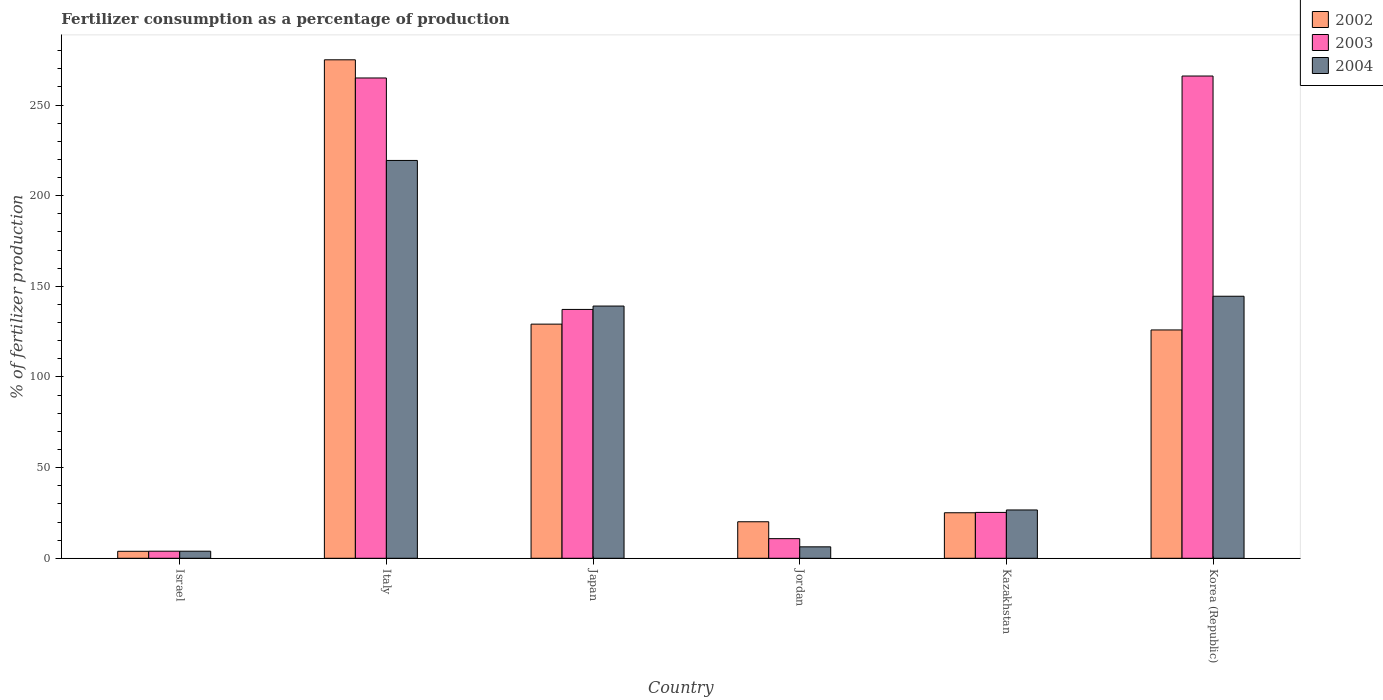How many different coloured bars are there?
Make the answer very short. 3. How many groups of bars are there?
Ensure brevity in your answer.  6. Are the number of bars per tick equal to the number of legend labels?
Keep it short and to the point. Yes. Are the number of bars on each tick of the X-axis equal?
Your response must be concise. Yes. How many bars are there on the 6th tick from the left?
Your response must be concise. 3. In how many cases, is the number of bars for a given country not equal to the number of legend labels?
Make the answer very short. 0. What is the percentage of fertilizers consumed in 2003 in Japan?
Ensure brevity in your answer.  137.27. Across all countries, what is the maximum percentage of fertilizers consumed in 2003?
Your answer should be very brief. 266.02. Across all countries, what is the minimum percentage of fertilizers consumed in 2002?
Your answer should be compact. 3.85. In which country was the percentage of fertilizers consumed in 2003 minimum?
Offer a terse response. Israel. What is the total percentage of fertilizers consumed in 2004 in the graph?
Give a very brief answer. 539.98. What is the difference between the percentage of fertilizers consumed in 2004 in Israel and that in Korea (Republic)?
Your answer should be compact. -140.63. What is the difference between the percentage of fertilizers consumed in 2002 in Jordan and the percentage of fertilizers consumed in 2004 in Korea (Republic)?
Offer a very short reply. -124.39. What is the average percentage of fertilizers consumed in 2003 per country?
Offer a terse response. 118.04. What is the difference between the percentage of fertilizers consumed of/in 2004 and percentage of fertilizers consumed of/in 2002 in Israel?
Provide a succinct answer. 0.05. In how many countries, is the percentage of fertilizers consumed in 2003 greater than 30 %?
Offer a terse response. 3. What is the ratio of the percentage of fertilizers consumed in 2003 in Jordan to that in Korea (Republic)?
Keep it short and to the point. 0.04. What is the difference between the highest and the second highest percentage of fertilizers consumed in 2004?
Your answer should be compact. -74.91. What is the difference between the highest and the lowest percentage of fertilizers consumed in 2004?
Keep it short and to the point. 215.54. Is the sum of the percentage of fertilizers consumed in 2002 in Japan and Jordan greater than the maximum percentage of fertilizers consumed in 2003 across all countries?
Keep it short and to the point. No. What does the 1st bar from the left in Italy represents?
Offer a very short reply. 2002. What does the 2nd bar from the right in Japan represents?
Your answer should be very brief. 2003. Is it the case that in every country, the sum of the percentage of fertilizers consumed in 2004 and percentage of fertilizers consumed in 2003 is greater than the percentage of fertilizers consumed in 2002?
Provide a succinct answer. No. Are all the bars in the graph horizontal?
Your response must be concise. No. How many countries are there in the graph?
Ensure brevity in your answer.  6. What is the difference between two consecutive major ticks on the Y-axis?
Your answer should be very brief. 50. Does the graph contain any zero values?
Offer a very short reply. No. Where does the legend appear in the graph?
Provide a short and direct response. Top right. How many legend labels are there?
Provide a succinct answer. 3. How are the legend labels stacked?
Make the answer very short. Vertical. What is the title of the graph?
Your response must be concise. Fertilizer consumption as a percentage of production. Does "2009" appear as one of the legend labels in the graph?
Your response must be concise. No. What is the label or title of the Y-axis?
Provide a short and direct response. % of fertilizer production. What is the % of fertilizer production of 2002 in Israel?
Keep it short and to the point. 3.85. What is the % of fertilizer production of 2003 in Israel?
Ensure brevity in your answer.  3.9. What is the % of fertilizer production of 2004 in Israel?
Ensure brevity in your answer.  3.9. What is the % of fertilizer production of 2002 in Italy?
Ensure brevity in your answer.  274.97. What is the % of fertilizer production in 2003 in Italy?
Your answer should be compact. 264.94. What is the % of fertilizer production of 2004 in Italy?
Your answer should be very brief. 219.45. What is the % of fertilizer production of 2002 in Japan?
Provide a short and direct response. 129.16. What is the % of fertilizer production of 2003 in Japan?
Offer a terse response. 137.27. What is the % of fertilizer production of 2004 in Japan?
Provide a short and direct response. 139.13. What is the % of fertilizer production in 2002 in Jordan?
Make the answer very short. 20.14. What is the % of fertilizer production of 2003 in Jordan?
Offer a very short reply. 10.83. What is the % of fertilizer production of 2004 in Jordan?
Provide a succinct answer. 6.31. What is the % of fertilizer production in 2002 in Kazakhstan?
Provide a short and direct response. 25.11. What is the % of fertilizer production in 2003 in Kazakhstan?
Make the answer very short. 25.3. What is the % of fertilizer production of 2004 in Kazakhstan?
Offer a very short reply. 26.65. What is the % of fertilizer production in 2002 in Korea (Republic)?
Provide a succinct answer. 125.95. What is the % of fertilizer production in 2003 in Korea (Republic)?
Ensure brevity in your answer.  266.02. What is the % of fertilizer production of 2004 in Korea (Republic)?
Provide a short and direct response. 144.54. Across all countries, what is the maximum % of fertilizer production of 2002?
Ensure brevity in your answer.  274.97. Across all countries, what is the maximum % of fertilizer production in 2003?
Your response must be concise. 266.02. Across all countries, what is the maximum % of fertilizer production of 2004?
Your answer should be compact. 219.45. Across all countries, what is the minimum % of fertilizer production of 2002?
Make the answer very short. 3.85. Across all countries, what is the minimum % of fertilizer production of 2003?
Your answer should be very brief. 3.9. Across all countries, what is the minimum % of fertilizer production in 2004?
Your answer should be compact. 3.9. What is the total % of fertilizer production of 2002 in the graph?
Give a very brief answer. 579.18. What is the total % of fertilizer production in 2003 in the graph?
Offer a very short reply. 708.26. What is the total % of fertilizer production in 2004 in the graph?
Make the answer very short. 539.98. What is the difference between the % of fertilizer production of 2002 in Israel and that in Italy?
Provide a short and direct response. -271.12. What is the difference between the % of fertilizer production of 2003 in Israel and that in Italy?
Provide a succinct answer. -261.04. What is the difference between the % of fertilizer production in 2004 in Israel and that in Italy?
Offer a very short reply. -215.54. What is the difference between the % of fertilizer production in 2002 in Israel and that in Japan?
Provide a succinct answer. -125.31. What is the difference between the % of fertilizer production in 2003 in Israel and that in Japan?
Your answer should be very brief. -133.36. What is the difference between the % of fertilizer production of 2004 in Israel and that in Japan?
Your answer should be very brief. -135.23. What is the difference between the % of fertilizer production in 2002 in Israel and that in Jordan?
Offer a very short reply. -16.29. What is the difference between the % of fertilizer production in 2003 in Israel and that in Jordan?
Make the answer very short. -6.92. What is the difference between the % of fertilizer production of 2004 in Israel and that in Jordan?
Offer a very short reply. -2.41. What is the difference between the % of fertilizer production of 2002 in Israel and that in Kazakhstan?
Your answer should be very brief. -21.25. What is the difference between the % of fertilizer production of 2003 in Israel and that in Kazakhstan?
Keep it short and to the point. -21.39. What is the difference between the % of fertilizer production in 2004 in Israel and that in Kazakhstan?
Provide a short and direct response. -22.74. What is the difference between the % of fertilizer production of 2002 in Israel and that in Korea (Republic)?
Your response must be concise. -122.1. What is the difference between the % of fertilizer production of 2003 in Israel and that in Korea (Republic)?
Offer a terse response. -262.12. What is the difference between the % of fertilizer production in 2004 in Israel and that in Korea (Republic)?
Offer a terse response. -140.63. What is the difference between the % of fertilizer production of 2002 in Italy and that in Japan?
Offer a very short reply. 145.81. What is the difference between the % of fertilizer production of 2003 in Italy and that in Japan?
Provide a short and direct response. 127.67. What is the difference between the % of fertilizer production of 2004 in Italy and that in Japan?
Ensure brevity in your answer.  80.32. What is the difference between the % of fertilizer production in 2002 in Italy and that in Jordan?
Give a very brief answer. 254.83. What is the difference between the % of fertilizer production in 2003 in Italy and that in Jordan?
Provide a short and direct response. 254.12. What is the difference between the % of fertilizer production in 2004 in Italy and that in Jordan?
Your response must be concise. 213.14. What is the difference between the % of fertilizer production in 2002 in Italy and that in Kazakhstan?
Provide a succinct answer. 249.86. What is the difference between the % of fertilizer production of 2003 in Italy and that in Kazakhstan?
Give a very brief answer. 239.64. What is the difference between the % of fertilizer production of 2004 in Italy and that in Kazakhstan?
Offer a terse response. 192.8. What is the difference between the % of fertilizer production of 2002 in Italy and that in Korea (Republic)?
Ensure brevity in your answer.  149.02. What is the difference between the % of fertilizer production of 2003 in Italy and that in Korea (Republic)?
Provide a succinct answer. -1.08. What is the difference between the % of fertilizer production of 2004 in Italy and that in Korea (Republic)?
Your answer should be very brief. 74.91. What is the difference between the % of fertilizer production in 2002 in Japan and that in Jordan?
Offer a very short reply. 109.02. What is the difference between the % of fertilizer production of 2003 in Japan and that in Jordan?
Your answer should be compact. 126.44. What is the difference between the % of fertilizer production of 2004 in Japan and that in Jordan?
Ensure brevity in your answer.  132.82. What is the difference between the % of fertilizer production of 2002 in Japan and that in Kazakhstan?
Make the answer very short. 104.05. What is the difference between the % of fertilizer production of 2003 in Japan and that in Kazakhstan?
Offer a terse response. 111.97. What is the difference between the % of fertilizer production of 2004 in Japan and that in Kazakhstan?
Keep it short and to the point. 112.49. What is the difference between the % of fertilizer production in 2002 in Japan and that in Korea (Republic)?
Provide a succinct answer. 3.21. What is the difference between the % of fertilizer production of 2003 in Japan and that in Korea (Republic)?
Your answer should be compact. -128.76. What is the difference between the % of fertilizer production of 2004 in Japan and that in Korea (Republic)?
Make the answer very short. -5.41. What is the difference between the % of fertilizer production in 2002 in Jordan and that in Kazakhstan?
Your response must be concise. -4.96. What is the difference between the % of fertilizer production in 2003 in Jordan and that in Kazakhstan?
Provide a succinct answer. -14.47. What is the difference between the % of fertilizer production in 2004 in Jordan and that in Kazakhstan?
Your answer should be compact. -20.34. What is the difference between the % of fertilizer production in 2002 in Jordan and that in Korea (Republic)?
Keep it short and to the point. -105.81. What is the difference between the % of fertilizer production in 2003 in Jordan and that in Korea (Republic)?
Give a very brief answer. -255.2. What is the difference between the % of fertilizer production of 2004 in Jordan and that in Korea (Republic)?
Your response must be concise. -138.23. What is the difference between the % of fertilizer production of 2002 in Kazakhstan and that in Korea (Republic)?
Your answer should be compact. -100.84. What is the difference between the % of fertilizer production in 2003 in Kazakhstan and that in Korea (Republic)?
Your answer should be very brief. -240.72. What is the difference between the % of fertilizer production in 2004 in Kazakhstan and that in Korea (Republic)?
Your answer should be compact. -117.89. What is the difference between the % of fertilizer production of 2002 in Israel and the % of fertilizer production of 2003 in Italy?
Your answer should be compact. -261.09. What is the difference between the % of fertilizer production in 2002 in Israel and the % of fertilizer production in 2004 in Italy?
Ensure brevity in your answer.  -215.59. What is the difference between the % of fertilizer production in 2003 in Israel and the % of fertilizer production in 2004 in Italy?
Offer a very short reply. -215.54. What is the difference between the % of fertilizer production in 2002 in Israel and the % of fertilizer production in 2003 in Japan?
Provide a succinct answer. -133.41. What is the difference between the % of fertilizer production of 2002 in Israel and the % of fertilizer production of 2004 in Japan?
Keep it short and to the point. -135.28. What is the difference between the % of fertilizer production in 2003 in Israel and the % of fertilizer production in 2004 in Japan?
Your answer should be very brief. -135.23. What is the difference between the % of fertilizer production in 2002 in Israel and the % of fertilizer production in 2003 in Jordan?
Keep it short and to the point. -6.97. What is the difference between the % of fertilizer production in 2002 in Israel and the % of fertilizer production in 2004 in Jordan?
Your response must be concise. -2.46. What is the difference between the % of fertilizer production of 2003 in Israel and the % of fertilizer production of 2004 in Jordan?
Your response must be concise. -2.41. What is the difference between the % of fertilizer production of 2002 in Israel and the % of fertilizer production of 2003 in Kazakhstan?
Your response must be concise. -21.45. What is the difference between the % of fertilizer production in 2002 in Israel and the % of fertilizer production in 2004 in Kazakhstan?
Your answer should be compact. -22.79. What is the difference between the % of fertilizer production in 2003 in Israel and the % of fertilizer production in 2004 in Kazakhstan?
Offer a terse response. -22.74. What is the difference between the % of fertilizer production of 2002 in Israel and the % of fertilizer production of 2003 in Korea (Republic)?
Your answer should be compact. -262.17. What is the difference between the % of fertilizer production in 2002 in Israel and the % of fertilizer production in 2004 in Korea (Republic)?
Your answer should be very brief. -140.69. What is the difference between the % of fertilizer production in 2003 in Israel and the % of fertilizer production in 2004 in Korea (Republic)?
Offer a very short reply. -140.63. What is the difference between the % of fertilizer production of 2002 in Italy and the % of fertilizer production of 2003 in Japan?
Ensure brevity in your answer.  137.7. What is the difference between the % of fertilizer production of 2002 in Italy and the % of fertilizer production of 2004 in Japan?
Offer a terse response. 135.84. What is the difference between the % of fertilizer production in 2003 in Italy and the % of fertilizer production in 2004 in Japan?
Offer a terse response. 125.81. What is the difference between the % of fertilizer production in 2002 in Italy and the % of fertilizer production in 2003 in Jordan?
Your answer should be very brief. 264.14. What is the difference between the % of fertilizer production of 2002 in Italy and the % of fertilizer production of 2004 in Jordan?
Ensure brevity in your answer.  268.66. What is the difference between the % of fertilizer production in 2003 in Italy and the % of fertilizer production in 2004 in Jordan?
Provide a short and direct response. 258.63. What is the difference between the % of fertilizer production in 2002 in Italy and the % of fertilizer production in 2003 in Kazakhstan?
Offer a very short reply. 249.67. What is the difference between the % of fertilizer production of 2002 in Italy and the % of fertilizer production of 2004 in Kazakhstan?
Ensure brevity in your answer.  248.32. What is the difference between the % of fertilizer production of 2003 in Italy and the % of fertilizer production of 2004 in Kazakhstan?
Keep it short and to the point. 238.3. What is the difference between the % of fertilizer production in 2002 in Italy and the % of fertilizer production in 2003 in Korea (Republic)?
Provide a short and direct response. 8.95. What is the difference between the % of fertilizer production of 2002 in Italy and the % of fertilizer production of 2004 in Korea (Republic)?
Your answer should be compact. 130.43. What is the difference between the % of fertilizer production in 2003 in Italy and the % of fertilizer production in 2004 in Korea (Republic)?
Ensure brevity in your answer.  120.4. What is the difference between the % of fertilizer production of 2002 in Japan and the % of fertilizer production of 2003 in Jordan?
Your answer should be very brief. 118.33. What is the difference between the % of fertilizer production in 2002 in Japan and the % of fertilizer production in 2004 in Jordan?
Your answer should be very brief. 122.85. What is the difference between the % of fertilizer production of 2003 in Japan and the % of fertilizer production of 2004 in Jordan?
Your response must be concise. 130.96. What is the difference between the % of fertilizer production in 2002 in Japan and the % of fertilizer production in 2003 in Kazakhstan?
Your answer should be very brief. 103.86. What is the difference between the % of fertilizer production in 2002 in Japan and the % of fertilizer production in 2004 in Kazakhstan?
Offer a very short reply. 102.51. What is the difference between the % of fertilizer production in 2003 in Japan and the % of fertilizer production in 2004 in Kazakhstan?
Give a very brief answer. 110.62. What is the difference between the % of fertilizer production in 2002 in Japan and the % of fertilizer production in 2003 in Korea (Republic)?
Ensure brevity in your answer.  -136.86. What is the difference between the % of fertilizer production in 2002 in Japan and the % of fertilizer production in 2004 in Korea (Republic)?
Ensure brevity in your answer.  -15.38. What is the difference between the % of fertilizer production of 2003 in Japan and the % of fertilizer production of 2004 in Korea (Republic)?
Offer a terse response. -7.27. What is the difference between the % of fertilizer production in 2002 in Jordan and the % of fertilizer production in 2003 in Kazakhstan?
Offer a very short reply. -5.16. What is the difference between the % of fertilizer production in 2002 in Jordan and the % of fertilizer production in 2004 in Kazakhstan?
Provide a short and direct response. -6.5. What is the difference between the % of fertilizer production of 2003 in Jordan and the % of fertilizer production of 2004 in Kazakhstan?
Your answer should be very brief. -15.82. What is the difference between the % of fertilizer production of 2002 in Jordan and the % of fertilizer production of 2003 in Korea (Republic)?
Give a very brief answer. -245.88. What is the difference between the % of fertilizer production of 2002 in Jordan and the % of fertilizer production of 2004 in Korea (Republic)?
Offer a very short reply. -124.39. What is the difference between the % of fertilizer production in 2003 in Jordan and the % of fertilizer production in 2004 in Korea (Republic)?
Offer a very short reply. -133.71. What is the difference between the % of fertilizer production of 2002 in Kazakhstan and the % of fertilizer production of 2003 in Korea (Republic)?
Make the answer very short. -240.92. What is the difference between the % of fertilizer production of 2002 in Kazakhstan and the % of fertilizer production of 2004 in Korea (Republic)?
Offer a terse response. -119.43. What is the difference between the % of fertilizer production in 2003 in Kazakhstan and the % of fertilizer production in 2004 in Korea (Republic)?
Your answer should be compact. -119.24. What is the average % of fertilizer production of 2002 per country?
Provide a succinct answer. 96.53. What is the average % of fertilizer production of 2003 per country?
Your answer should be compact. 118.04. What is the average % of fertilizer production of 2004 per country?
Provide a short and direct response. 90. What is the difference between the % of fertilizer production in 2002 and % of fertilizer production in 2003 in Israel?
Your answer should be compact. -0.05. What is the difference between the % of fertilizer production of 2002 and % of fertilizer production of 2004 in Israel?
Give a very brief answer. -0.05. What is the difference between the % of fertilizer production of 2003 and % of fertilizer production of 2004 in Israel?
Make the answer very short. -0. What is the difference between the % of fertilizer production of 2002 and % of fertilizer production of 2003 in Italy?
Give a very brief answer. 10.03. What is the difference between the % of fertilizer production in 2002 and % of fertilizer production in 2004 in Italy?
Offer a very short reply. 55.52. What is the difference between the % of fertilizer production in 2003 and % of fertilizer production in 2004 in Italy?
Provide a short and direct response. 45.5. What is the difference between the % of fertilizer production of 2002 and % of fertilizer production of 2003 in Japan?
Your answer should be compact. -8.11. What is the difference between the % of fertilizer production in 2002 and % of fertilizer production in 2004 in Japan?
Make the answer very short. -9.97. What is the difference between the % of fertilizer production in 2003 and % of fertilizer production in 2004 in Japan?
Provide a short and direct response. -1.86. What is the difference between the % of fertilizer production of 2002 and % of fertilizer production of 2003 in Jordan?
Offer a terse response. 9.32. What is the difference between the % of fertilizer production in 2002 and % of fertilizer production in 2004 in Jordan?
Ensure brevity in your answer.  13.83. What is the difference between the % of fertilizer production of 2003 and % of fertilizer production of 2004 in Jordan?
Make the answer very short. 4.52. What is the difference between the % of fertilizer production in 2002 and % of fertilizer production in 2003 in Kazakhstan?
Offer a very short reply. -0.19. What is the difference between the % of fertilizer production of 2002 and % of fertilizer production of 2004 in Kazakhstan?
Your answer should be compact. -1.54. What is the difference between the % of fertilizer production in 2003 and % of fertilizer production in 2004 in Kazakhstan?
Your response must be concise. -1.35. What is the difference between the % of fertilizer production in 2002 and % of fertilizer production in 2003 in Korea (Republic)?
Keep it short and to the point. -140.07. What is the difference between the % of fertilizer production in 2002 and % of fertilizer production in 2004 in Korea (Republic)?
Provide a succinct answer. -18.59. What is the difference between the % of fertilizer production in 2003 and % of fertilizer production in 2004 in Korea (Republic)?
Make the answer very short. 121.49. What is the ratio of the % of fertilizer production in 2002 in Israel to that in Italy?
Your answer should be very brief. 0.01. What is the ratio of the % of fertilizer production in 2003 in Israel to that in Italy?
Give a very brief answer. 0.01. What is the ratio of the % of fertilizer production in 2004 in Israel to that in Italy?
Your answer should be very brief. 0.02. What is the ratio of the % of fertilizer production of 2002 in Israel to that in Japan?
Offer a terse response. 0.03. What is the ratio of the % of fertilizer production in 2003 in Israel to that in Japan?
Your answer should be very brief. 0.03. What is the ratio of the % of fertilizer production in 2004 in Israel to that in Japan?
Provide a succinct answer. 0.03. What is the ratio of the % of fertilizer production of 2002 in Israel to that in Jordan?
Give a very brief answer. 0.19. What is the ratio of the % of fertilizer production in 2003 in Israel to that in Jordan?
Your answer should be very brief. 0.36. What is the ratio of the % of fertilizer production of 2004 in Israel to that in Jordan?
Make the answer very short. 0.62. What is the ratio of the % of fertilizer production of 2002 in Israel to that in Kazakhstan?
Your answer should be very brief. 0.15. What is the ratio of the % of fertilizer production in 2003 in Israel to that in Kazakhstan?
Make the answer very short. 0.15. What is the ratio of the % of fertilizer production in 2004 in Israel to that in Kazakhstan?
Your answer should be compact. 0.15. What is the ratio of the % of fertilizer production of 2002 in Israel to that in Korea (Republic)?
Your answer should be compact. 0.03. What is the ratio of the % of fertilizer production in 2003 in Israel to that in Korea (Republic)?
Your response must be concise. 0.01. What is the ratio of the % of fertilizer production in 2004 in Israel to that in Korea (Republic)?
Your answer should be compact. 0.03. What is the ratio of the % of fertilizer production of 2002 in Italy to that in Japan?
Make the answer very short. 2.13. What is the ratio of the % of fertilizer production of 2003 in Italy to that in Japan?
Ensure brevity in your answer.  1.93. What is the ratio of the % of fertilizer production in 2004 in Italy to that in Japan?
Offer a very short reply. 1.58. What is the ratio of the % of fertilizer production in 2002 in Italy to that in Jordan?
Provide a succinct answer. 13.65. What is the ratio of the % of fertilizer production of 2003 in Italy to that in Jordan?
Provide a succinct answer. 24.47. What is the ratio of the % of fertilizer production of 2004 in Italy to that in Jordan?
Your response must be concise. 34.78. What is the ratio of the % of fertilizer production in 2002 in Italy to that in Kazakhstan?
Offer a very short reply. 10.95. What is the ratio of the % of fertilizer production in 2003 in Italy to that in Kazakhstan?
Provide a succinct answer. 10.47. What is the ratio of the % of fertilizer production in 2004 in Italy to that in Kazakhstan?
Your answer should be compact. 8.24. What is the ratio of the % of fertilizer production of 2002 in Italy to that in Korea (Republic)?
Keep it short and to the point. 2.18. What is the ratio of the % of fertilizer production in 2004 in Italy to that in Korea (Republic)?
Your response must be concise. 1.52. What is the ratio of the % of fertilizer production of 2002 in Japan to that in Jordan?
Your answer should be compact. 6.41. What is the ratio of the % of fertilizer production of 2003 in Japan to that in Jordan?
Make the answer very short. 12.68. What is the ratio of the % of fertilizer production in 2004 in Japan to that in Jordan?
Offer a very short reply. 22.05. What is the ratio of the % of fertilizer production in 2002 in Japan to that in Kazakhstan?
Offer a very short reply. 5.14. What is the ratio of the % of fertilizer production in 2003 in Japan to that in Kazakhstan?
Ensure brevity in your answer.  5.43. What is the ratio of the % of fertilizer production of 2004 in Japan to that in Kazakhstan?
Offer a terse response. 5.22. What is the ratio of the % of fertilizer production of 2002 in Japan to that in Korea (Republic)?
Your response must be concise. 1.03. What is the ratio of the % of fertilizer production in 2003 in Japan to that in Korea (Republic)?
Provide a succinct answer. 0.52. What is the ratio of the % of fertilizer production in 2004 in Japan to that in Korea (Republic)?
Keep it short and to the point. 0.96. What is the ratio of the % of fertilizer production in 2002 in Jordan to that in Kazakhstan?
Give a very brief answer. 0.8. What is the ratio of the % of fertilizer production in 2003 in Jordan to that in Kazakhstan?
Provide a succinct answer. 0.43. What is the ratio of the % of fertilizer production in 2004 in Jordan to that in Kazakhstan?
Your response must be concise. 0.24. What is the ratio of the % of fertilizer production in 2002 in Jordan to that in Korea (Republic)?
Keep it short and to the point. 0.16. What is the ratio of the % of fertilizer production in 2003 in Jordan to that in Korea (Republic)?
Keep it short and to the point. 0.04. What is the ratio of the % of fertilizer production of 2004 in Jordan to that in Korea (Republic)?
Provide a short and direct response. 0.04. What is the ratio of the % of fertilizer production of 2002 in Kazakhstan to that in Korea (Republic)?
Keep it short and to the point. 0.2. What is the ratio of the % of fertilizer production of 2003 in Kazakhstan to that in Korea (Republic)?
Give a very brief answer. 0.1. What is the ratio of the % of fertilizer production in 2004 in Kazakhstan to that in Korea (Republic)?
Provide a short and direct response. 0.18. What is the difference between the highest and the second highest % of fertilizer production in 2002?
Provide a succinct answer. 145.81. What is the difference between the highest and the second highest % of fertilizer production in 2003?
Offer a very short reply. 1.08. What is the difference between the highest and the second highest % of fertilizer production of 2004?
Your answer should be very brief. 74.91. What is the difference between the highest and the lowest % of fertilizer production of 2002?
Ensure brevity in your answer.  271.12. What is the difference between the highest and the lowest % of fertilizer production of 2003?
Ensure brevity in your answer.  262.12. What is the difference between the highest and the lowest % of fertilizer production of 2004?
Your answer should be compact. 215.54. 